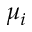<formula> <loc_0><loc_0><loc_500><loc_500>\mu _ { i }</formula> 